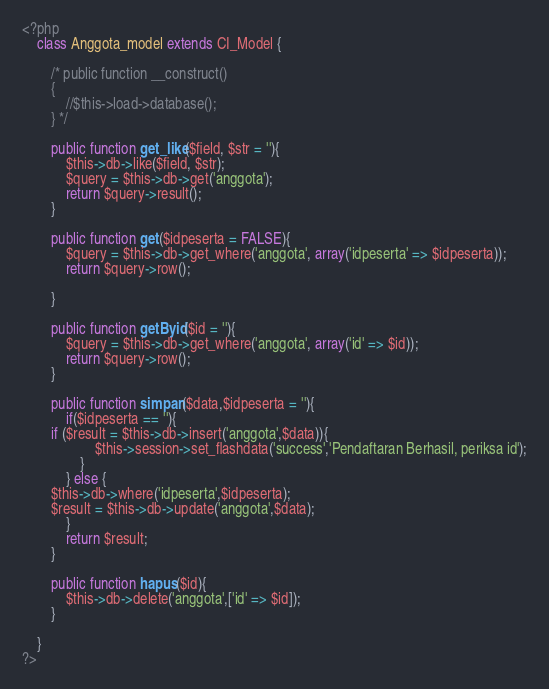Convert code to text. <code><loc_0><loc_0><loc_500><loc_500><_PHP_><?php
	class Anggota_model extends CI_Model {
		
		/* public function __construct()
		{
			//$this->load->database();
		} */
		
		public function get_like($field, $str = ''){
			$this->db->like($field, $str);
			$query = $this->db->get('anggota');
			return $query->result();
		}
		
		public function get($idpeserta = FALSE){	
			$query = $this->db->get_where('anggota', array('idpeserta' => $idpeserta));
			return $query->row();
			
		}
		
		public function getByid($id = ''){			
			$query = $this->db->get_where('anggota', array('id' => $id));
			return $query->row();
		}
		
		public function simpan($data,$idpeserta = ''){
			if($idpeserta == ''){
        if ($result = $this->db->insert('anggota',$data)){
					$this->session->set_flashdata('success','Pendaftaran Berhasil, periksa id');
				}
			} else {
        $this->db->where('idpeserta',$idpeserta);
        $result = $this->db->update('anggota',$data);  
			}       
			return $result;
		}
				
		public function hapus($id){
			$this->db->delete('anggota',['id' => $id]);
		}
		
	}
?></code> 